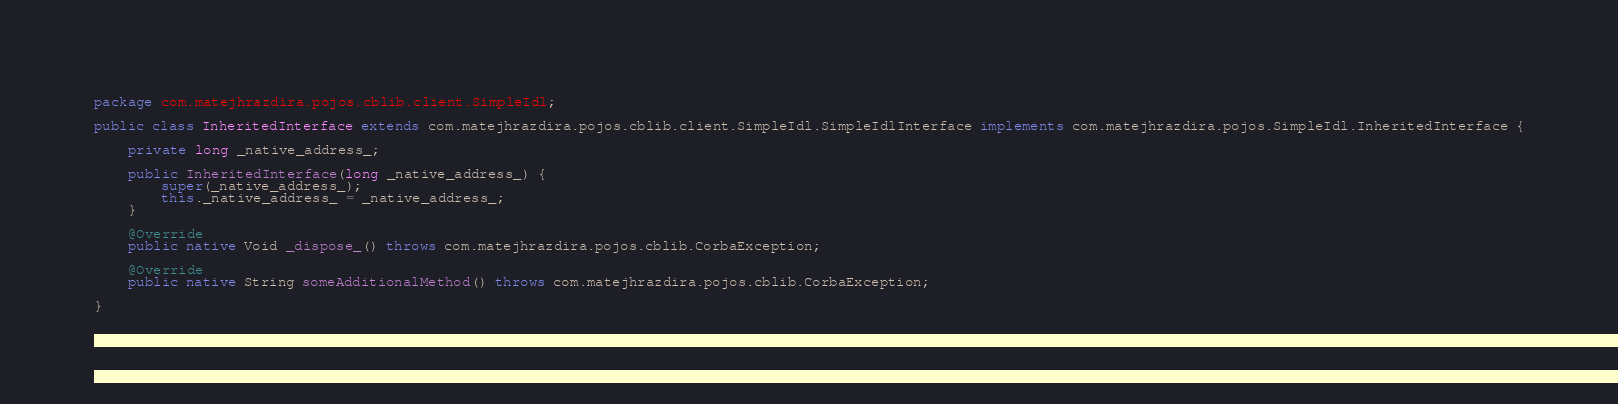<code> <loc_0><loc_0><loc_500><loc_500><_Java_>package com.matejhrazdira.pojos.cblib.client.SimpleIdl;

public class InheritedInterface extends com.matejhrazdira.pojos.cblib.client.SimpleIdl.SimpleIdlInterface implements com.matejhrazdira.pojos.SimpleIdl.InheritedInterface {

	private long _native_address_;

	public InheritedInterface(long _native_address_) {
		super(_native_address_);
		this._native_address_ = _native_address_;
	}

	@Override
	public native Void _dispose_() throws com.matejhrazdira.pojos.cblib.CorbaException;

	@Override
	public native String someAdditionalMethod() throws com.matejhrazdira.pojos.cblib.CorbaException;

}
</code> 